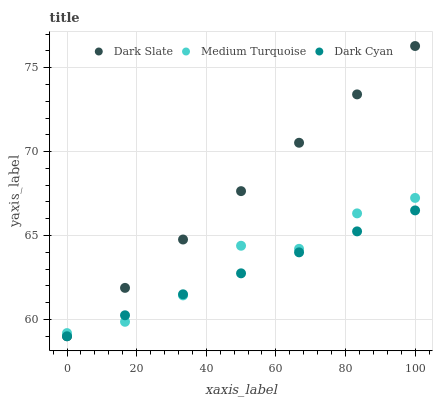Does Dark Cyan have the minimum area under the curve?
Answer yes or no. Yes. Does Dark Slate have the maximum area under the curve?
Answer yes or no. Yes. Does Medium Turquoise have the minimum area under the curve?
Answer yes or no. No. Does Medium Turquoise have the maximum area under the curve?
Answer yes or no. No. Is Dark Cyan the smoothest?
Answer yes or no. Yes. Is Medium Turquoise the roughest?
Answer yes or no. Yes. Is Dark Slate the smoothest?
Answer yes or no. No. Is Dark Slate the roughest?
Answer yes or no. No. Does Dark Cyan have the lowest value?
Answer yes or no. Yes. Does Medium Turquoise have the lowest value?
Answer yes or no. No. Does Dark Slate have the highest value?
Answer yes or no. Yes. Does Medium Turquoise have the highest value?
Answer yes or no. No. Does Dark Cyan intersect Medium Turquoise?
Answer yes or no. Yes. Is Dark Cyan less than Medium Turquoise?
Answer yes or no. No. Is Dark Cyan greater than Medium Turquoise?
Answer yes or no. No. 